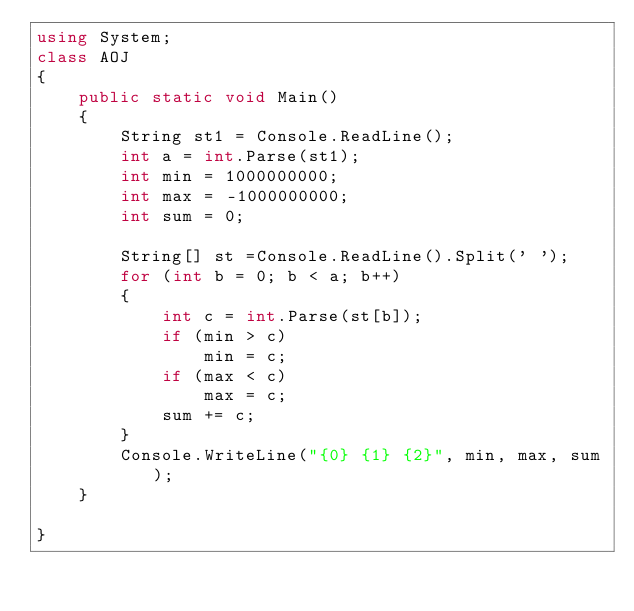Convert code to text. <code><loc_0><loc_0><loc_500><loc_500><_C#_>using System;
class AOJ
{
    public static void Main()
    {
        String st1 = Console.ReadLine();
        int a = int.Parse(st1);
        int min = 1000000000;
        int max = -1000000000;
        int sum = 0;

        String[] st =Console.ReadLine().Split(' ');
        for (int b = 0; b < a; b++)
        {
            int c = int.Parse(st[b]);
            if (min > c)
                min = c;
            if (max < c)
                max = c;
            sum += c;
        }
        Console.WriteLine("{0} {1} {2}", min, max, sum);
    }

}</code> 